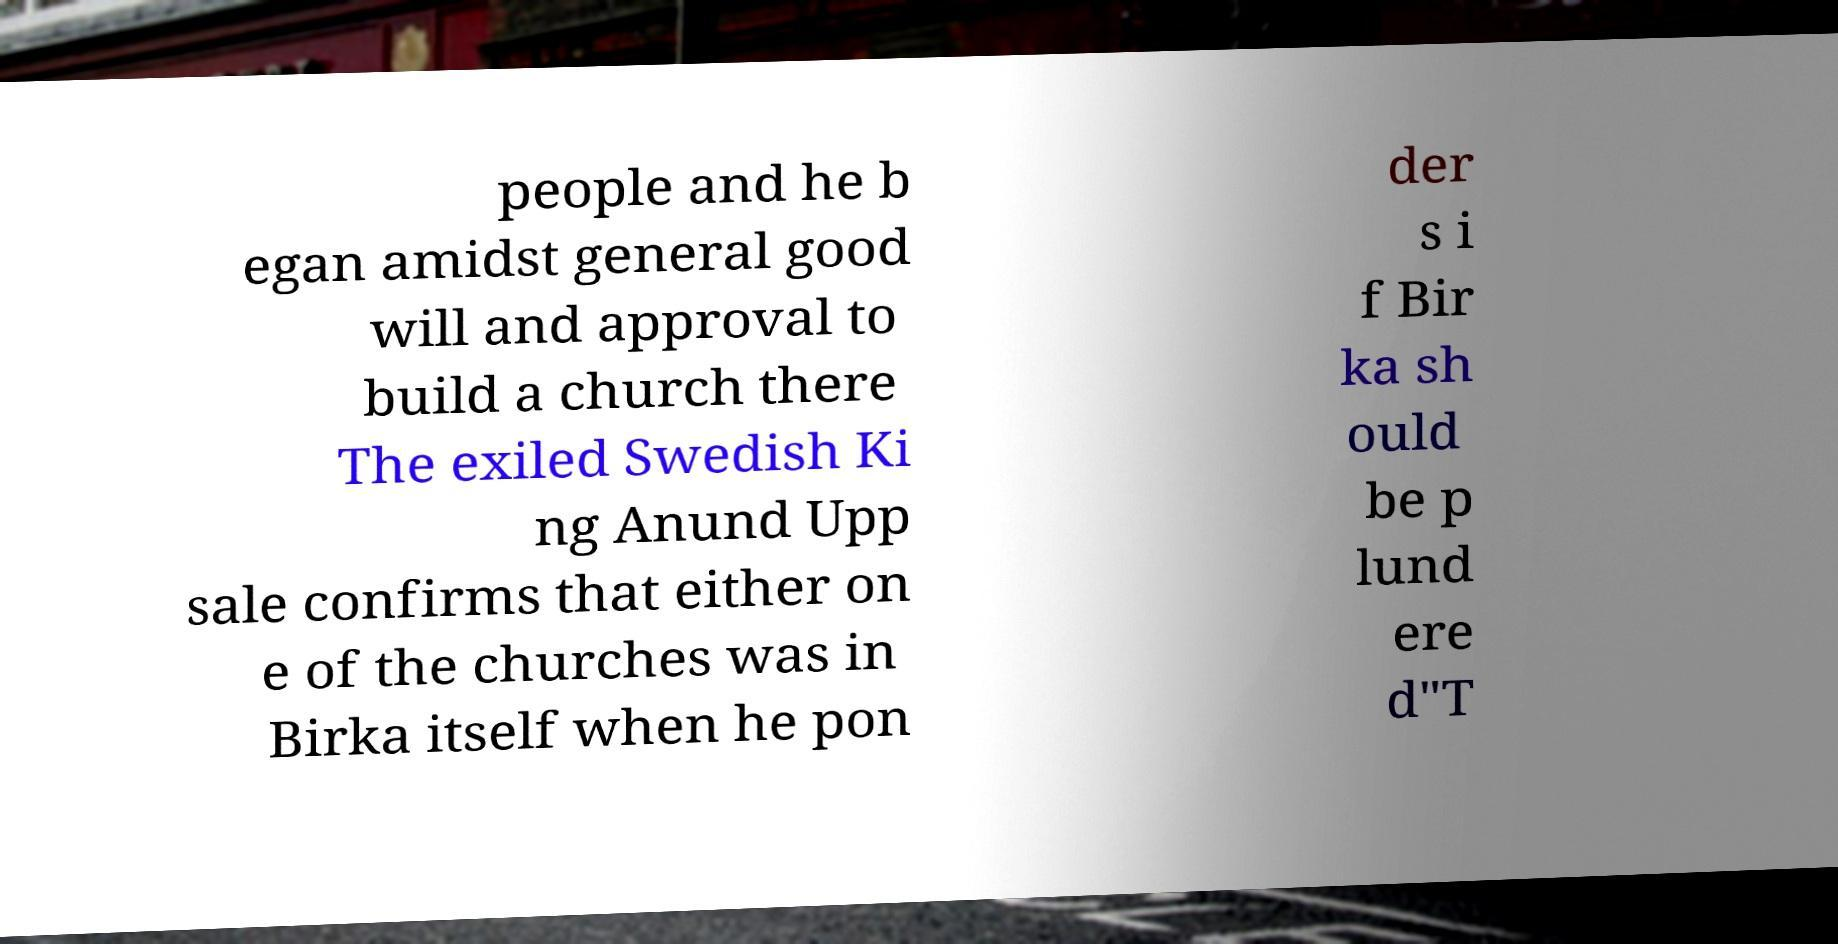Could you assist in decoding the text presented in this image and type it out clearly? people and he b egan amidst general good will and approval to build a church there The exiled Swedish Ki ng Anund Upp sale confirms that either on e of the churches was in Birka itself when he pon der s i f Bir ka sh ould be p lund ere d"T 